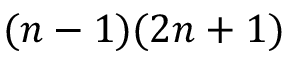<formula> <loc_0><loc_0><loc_500><loc_500>( n - 1 ) ( 2 n + 1 )</formula> 